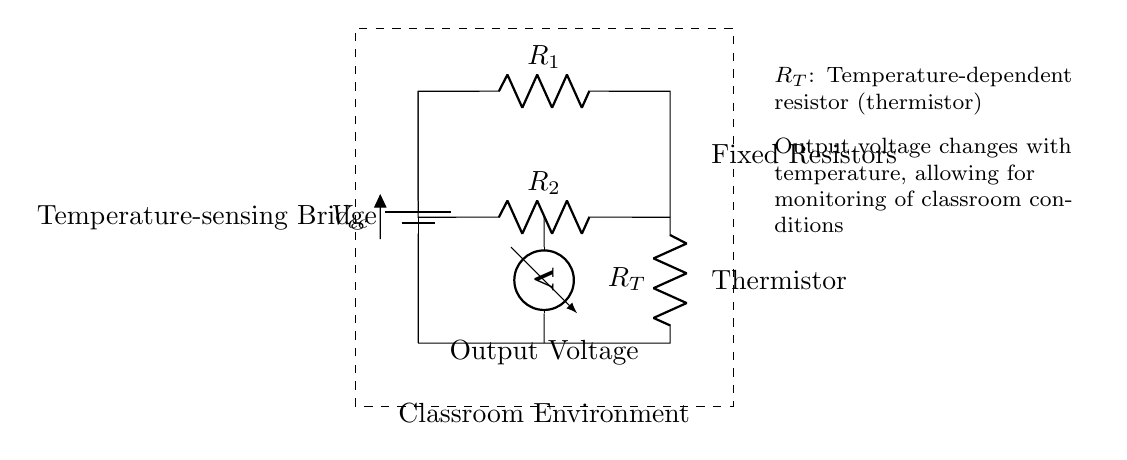What type of temperature sensor is used in this circuit? The circuit utilizes a thermistor (temperature-dependent resistor) to measure temperature changes. It is indicated in the diagram as R_T.
Answer: Thermistor What is the output of the bridge circuit? The anticipated output is a voltage, which represents the changes in temperature due to the varying resistance of the thermistor. This output can be viewed through the voltmeter.
Answer: Output Voltage How many fixed resistors are in the circuit? There are two fixed resistors present in this bridge circuit, labeled R_1 and R_2.
Answer: Two What happens to the output voltage as temperature increases? As the temperature rises, the resistance of the thermistor changes, which will likely result in a corresponding change in the output voltage, indicating a varying classroom condition.
Answer: Increases or decreases (depending on thermistor type) What is the purpose of the dashed rectangle in the diagram? The dashed rectangle signifies the boundary of the classroom environment being monitored, indicating that the entire circuit is designed to ensure optimal conditions within this area.
Answer: Classroom Environment What is connected to the voltage measurement point? A voltmeter is connected to the midpoint of the bridge circuit to measure the output voltage across the two nodes, helping to assess the response of the circuit to temperature changes.
Answer: Voltmeter 